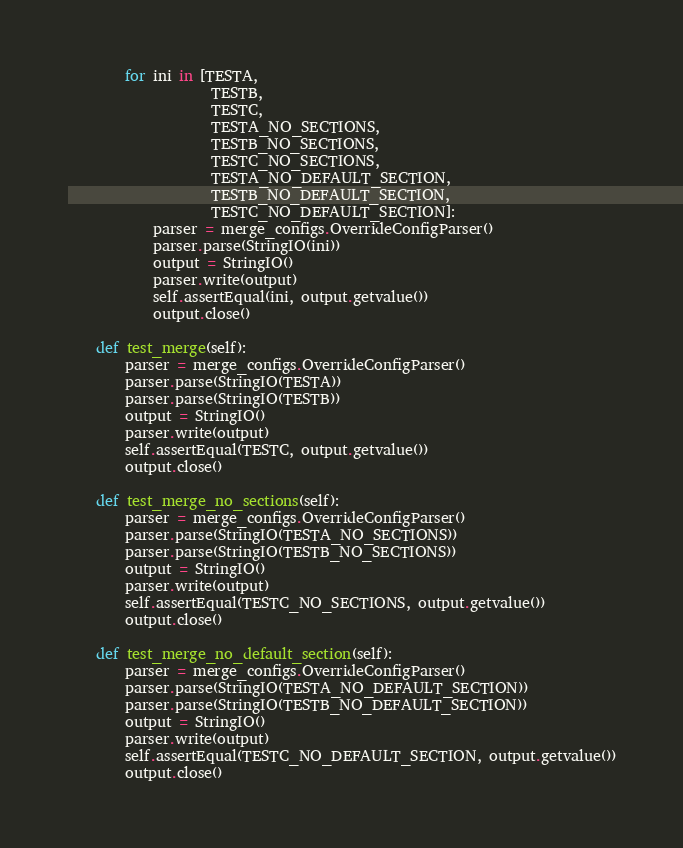<code> <loc_0><loc_0><loc_500><loc_500><_Python_>        for ini in [TESTA,
                    TESTB,
                    TESTC,
                    TESTA_NO_SECTIONS,
                    TESTB_NO_SECTIONS,
                    TESTC_NO_SECTIONS,
                    TESTA_NO_DEFAULT_SECTION,
                    TESTB_NO_DEFAULT_SECTION,
                    TESTC_NO_DEFAULT_SECTION]:
            parser = merge_configs.OverrideConfigParser()
            parser.parse(StringIO(ini))
            output = StringIO()
            parser.write(output)
            self.assertEqual(ini, output.getvalue())
            output.close()

    def test_merge(self):
        parser = merge_configs.OverrideConfigParser()
        parser.parse(StringIO(TESTA))
        parser.parse(StringIO(TESTB))
        output = StringIO()
        parser.write(output)
        self.assertEqual(TESTC, output.getvalue())
        output.close()

    def test_merge_no_sections(self):
        parser = merge_configs.OverrideConfigParser()
        parser.parse(StringIO(TESTA_NO_SECTIONS))
        parser.parse(StringIO(TESTB_NO_SECTIONS))
        output = StringIO()
        parser.write(output)
        self.assertEqual(TESTC_NO_SECTIONS, output.getvalue())
        output.close()

    def test_merge_no_default_section(self):
        parser = merge_configs.OverrideConfigParser()
        parser.parse(StringIO(TESTA_NO_DEFAULT_SECTION))
        parser.parse(StringIO(TESTB_NO_DEFAULT_SECTION))
        output = StringIO()
        parser.write(output)
        self.assertEqual(TESTC_NO_DEFAULT_SECTION, output.getvalue())
        output.close()
</code> 